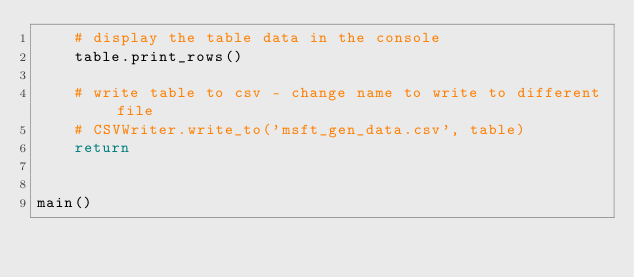Convert code to text. <code><loc_0><loc_0><loc_500><loc_500><_Python_>    # display the table data in the console
    table.print_rows()

    # write table to csv - change name to write to different file
    # CSVWriter.write_to('msft_gen_data.csv', table)
    return


main()
</code> 